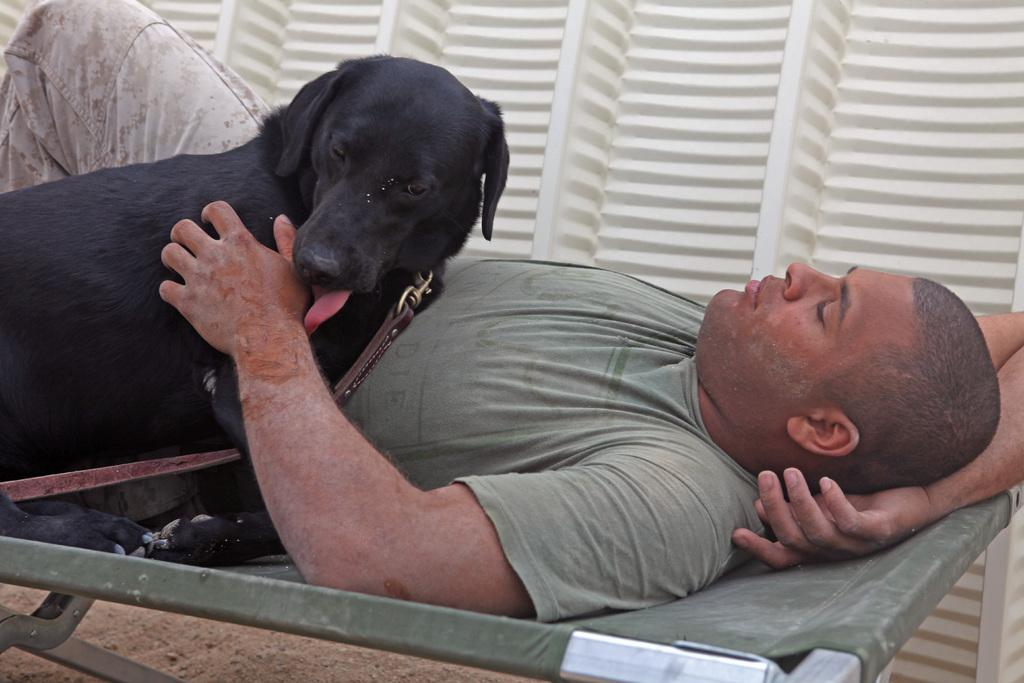What is the person in the image doing? The person is laying on a bed. What other living creature is present in the image? There is a dog in the image. What type of drum can be seen in the image? There is no drum present in the image. How many pigs are visible in the image? There are no pigs visible in the image. 